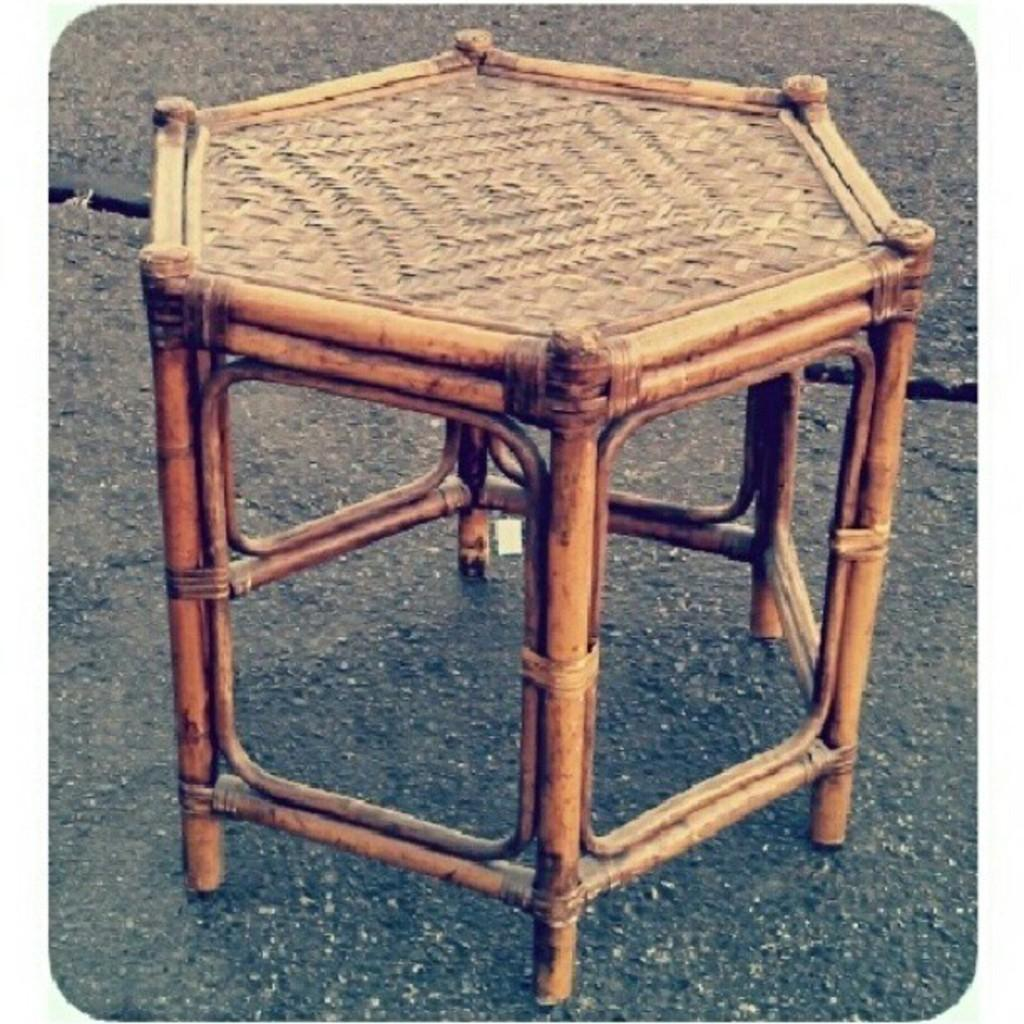What type of furniture is present in the image? There is a stool in the image. What material is the stool made of? The stool is made up of wood. Where is the stool located in the image? The stool is kept on the road. Can you provide an example of a yak in the image? There is no yak present in the image. How does the stool control the traffic on the road? The stool does not control the traffic on the road; it is simply a piece of furniture placed on the road. 